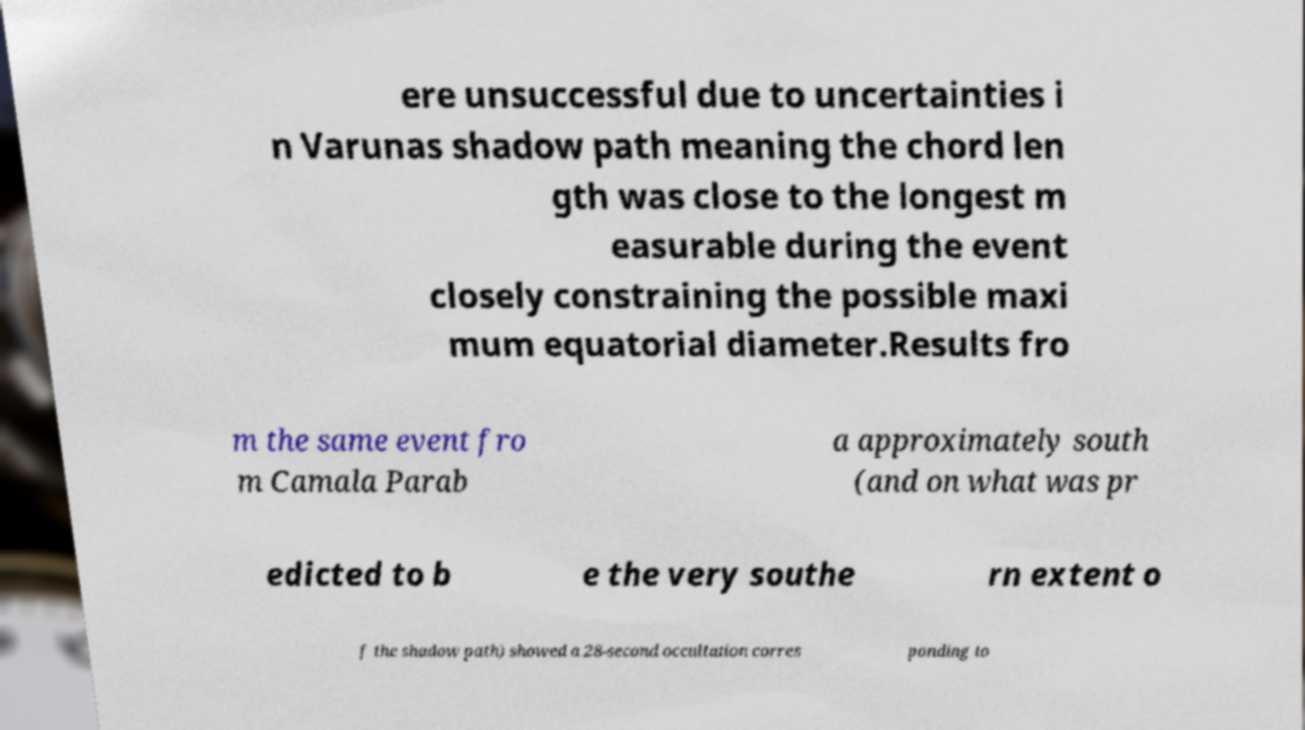Please read and relay the text visible in this image. What does it say? ere unsuccessful due to uncertainties i n Varunas shadow path meaning the chord len gth was close to the longest m easurable during the event closely constraining the possible maxi mum equatorial diameter.Results fro m the same event fro m Camala Parab a approximately south (and on what was pr edicted to b e the very southe rn extent o f the shadow path) showed a 28-second occultation corres ponding to 